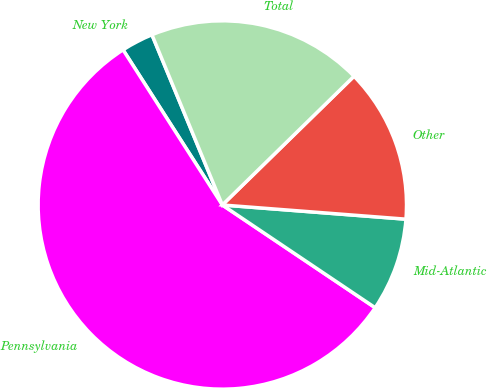<chart> <loc_0><loc_0><loc_500><loc_500><pie_chart><fcel>New York<fcel>Pennsylvania<fcel>Mid-Atlantic<fcel>Other<fcel>Total<nl><fcel>2.82%<fcel>56.53%<fcel>8.19%<fcel>13.55%<fcel>18.92%<nl></chart> 